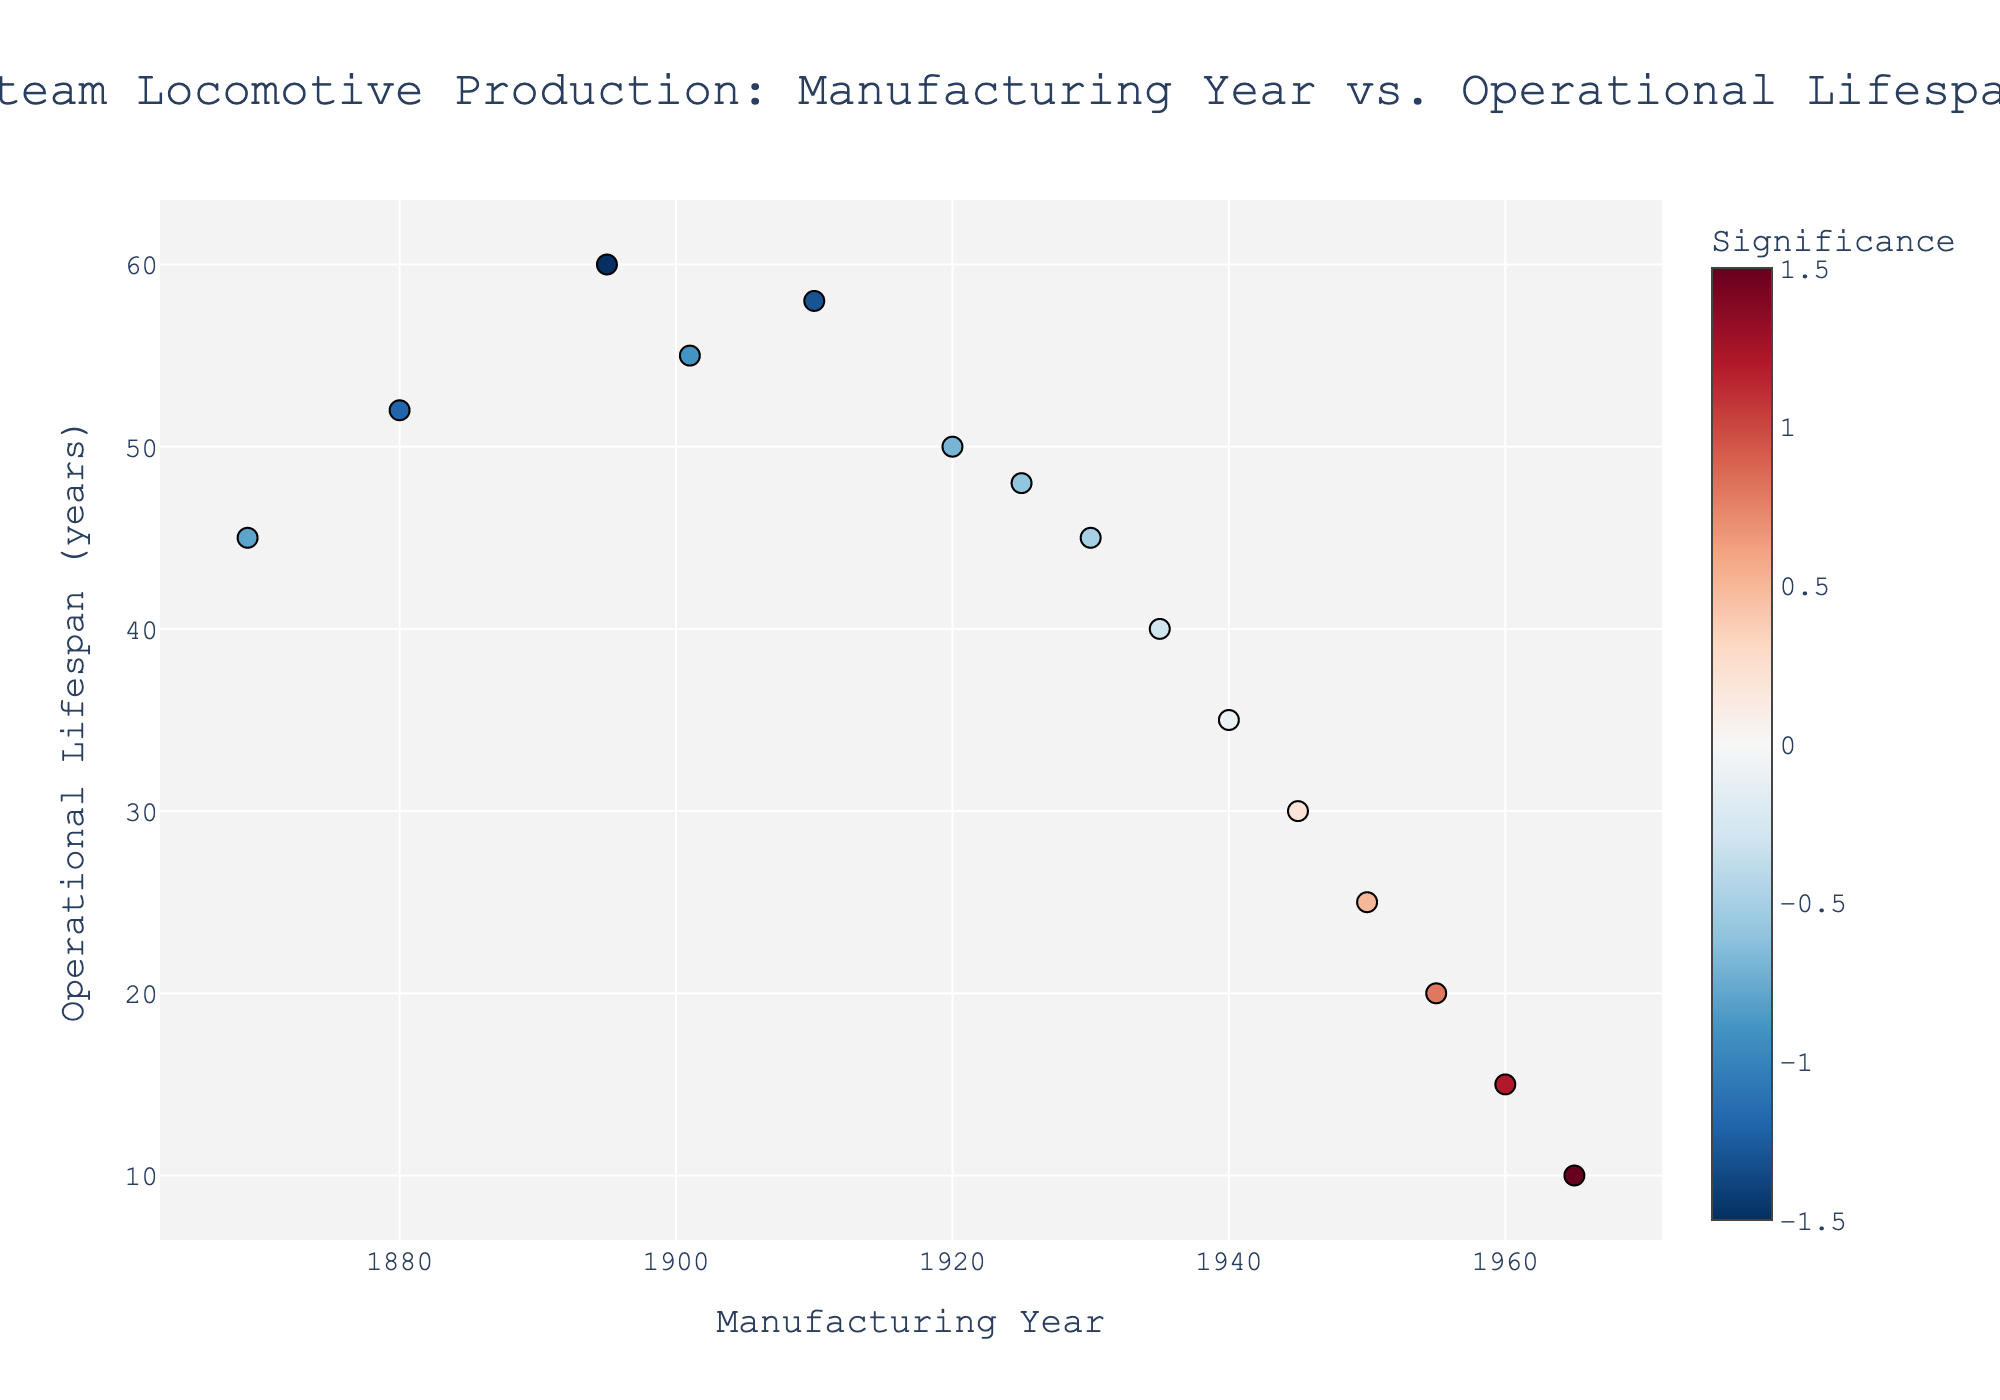What is the title of the plot? The title is prominently displayed at the top of the plot.
Answer: Steam Locomotive Production: Manufacturing Year vs. Operational Lifespan How many data points are shown in the plot? Count the number of markers plotted on the figure.
Answer: 15 What is the x-axis labeled as? The x-axis label is shown below the x-axis.
Answer: Manufacturing Year Which year had the longest operational lifespan for steam locomotives? Locate the highest y-value on the plot and find the corresponding x-value.
Answer: 1895 What is the color scale used in the plot? The color scale runs along the side of the plot, with colors changing from one end to the other.
Answer: RdBu_r Which year shows the lowest operational lifespan for steam locomotives? Locate the lowest y-value on the plot and find the corresponding x-value.
Answer: 1965 What is the average operational lifespan of steam locomotives produced before 1900? Identify the data points before 1900, sum their y-values, and divide by the number of such data points. (45+52+60) / 3
Answer: 52.33 years What is the trend of operational lifespan over the years? Identify the general direction of the data points from left to right.
Answer: Decreasing Which year had a significance of 0.5? Find the marker with the hover text showing "Significance: 0.5"
Answer: 1950 Between 1920 and 1950, which year had the highest operational lifespan? Locate the data points between 1920 and 1950 and identify the highest y-value among them.
Answer: 1920 